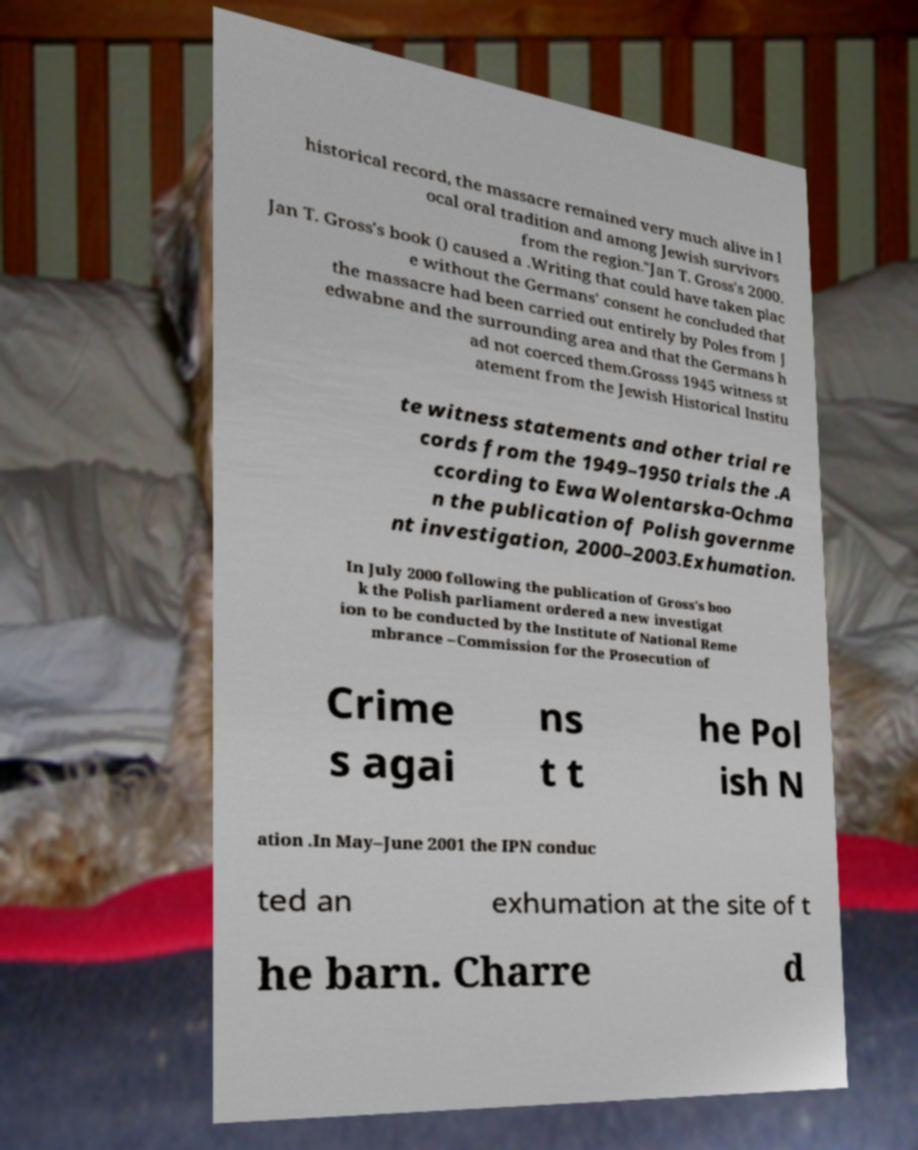Could you assist in decoding the text presented in this image and type it out clearly? historical record, the massacre remained very much alive in l ocal oral tradition and among Jewish survivors from the region."Jan T. Gross's 2000. Jan T. Gross's book () caused a .Writing that could have taken plac e without the Germans' consent he concluded that the massacre had been carried out entirely by Poles from J edwabne and the surrounding area and that the Germans h ad not coerced them.Grosss 1945 witness st atement from the Jewish Historical Institu te witness statements and other trial re cords from the 1949–1950 trials the .A ccording to Ewa Wolentarska-Ochma n the publication of Polish governme nt investigation, 2000–2003.Exhumation. In July 2000 following the publication of Gross's boo k the Polish parliament ordered a new investigat ion to be conducted by the Institute of National Reme mbrance –Commission for the Prosecution of Crime s agai ns t t he Pol ish N ation .In May–June 2001 the IPN conduc ted an exhumation at the site of t he barn. Charre d 